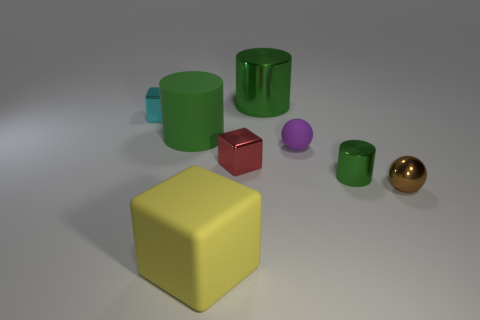Is there anything else that has the same material as the small brown sphere? Yes, the other objects in the image, such as the green cylinder, yellow cube, and the purple sphere, all appear to have a similarly smooth and reflective surface, indicating that they may be made of a material with properties like plastic or polished metal, similar to the small brown sphere. 